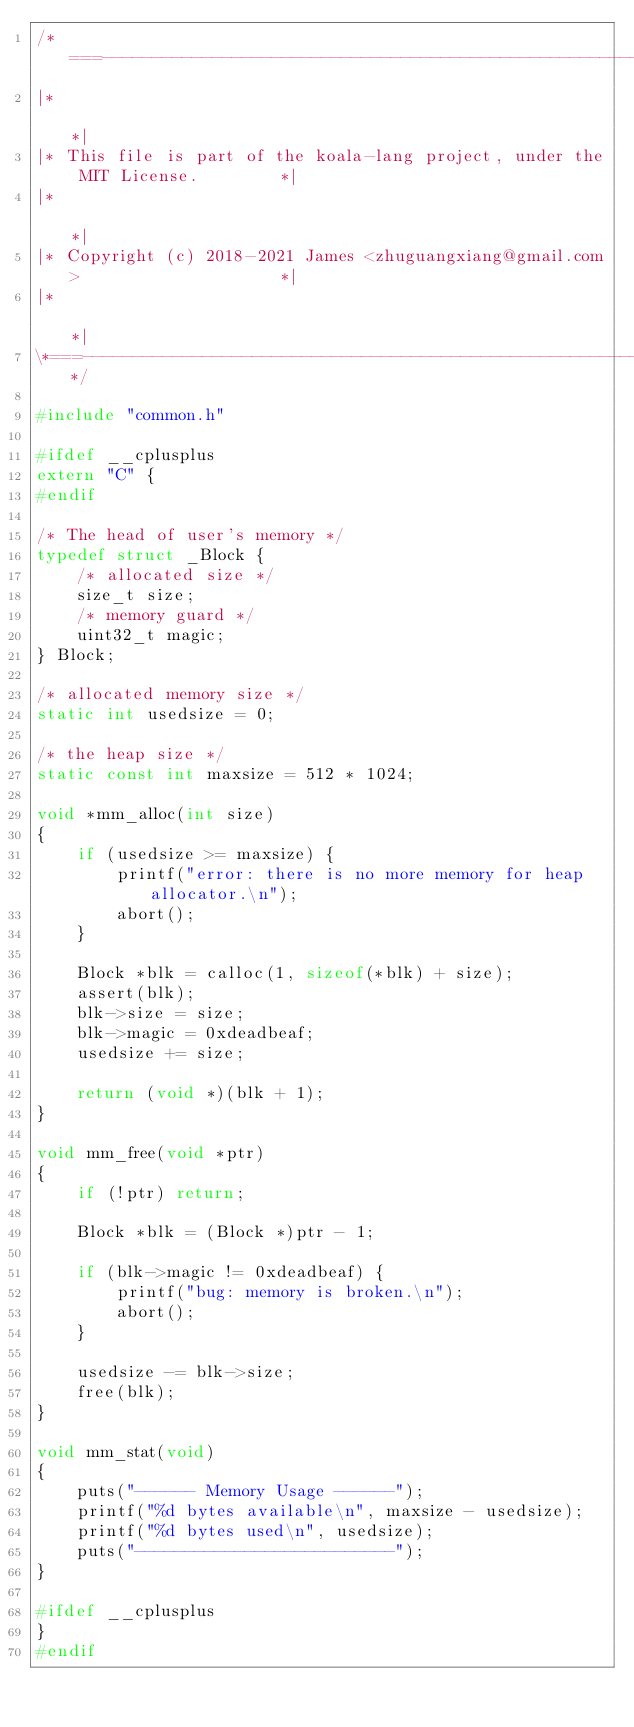<code> <loc_0><loc_0><loc_500><loc_500><_C_>/*===----------------------------------------------------------------------===*\
|*                                                                            *|
|* This file is part of the koala-lang project, under the MIT License.        *|
|*                                                                            *|
|* Copyright (c) 2018-2021 James <zhuguangxiang@gmail.com>                    *|
|*                                                                            *|
\*===----------------------------------------------------------------------===*/

#include "common.h"

#ifdef __cplusplus
extern "C" {
#endif

/* The head of user's memory */
typedef struct _Block {
    /* allocated size */
    size_t size;
    /* memory guard */
    uint32_t magic;
} Block;

/* allocated memory size */
static int usedsize = 0;

/* the heap size */
static const int maxsize = 512 * 1024;

void *mm_alloc(int size)
{
    if (usedsize >= maxsize) {
        printf("error: there is no more memory for heap allocator.\n");
        abort();
    }

    Block *blk = calloc(1, sizeof(*blk) + size);
    assert(blk);
    blk->size = size;
    blk->magic = 0xdeadbeaf;
    usedsize += size;

    return (void *)(blk + 1);
}

void mm_free(void *ptr)
{
    if (!ptr) return;

    Block *blk = (Block *)ptr - 1;

    if (blk->magic != 0xdeadbeaf) {
        printf("bug: memory is broken.\n");
        abort();
    }

    usedsize -= blk->size;
    free(blk);
}

void mm_stat(void)
{
    puts("------ Memory Usage ------");
    printf("%d bytes available\n", maxsize - usedsize);
    printf("%d bytes used\n", usedsize);
    puts("--------------------------");
}

#ifdef __cplusplus
}
#endif
</code> 